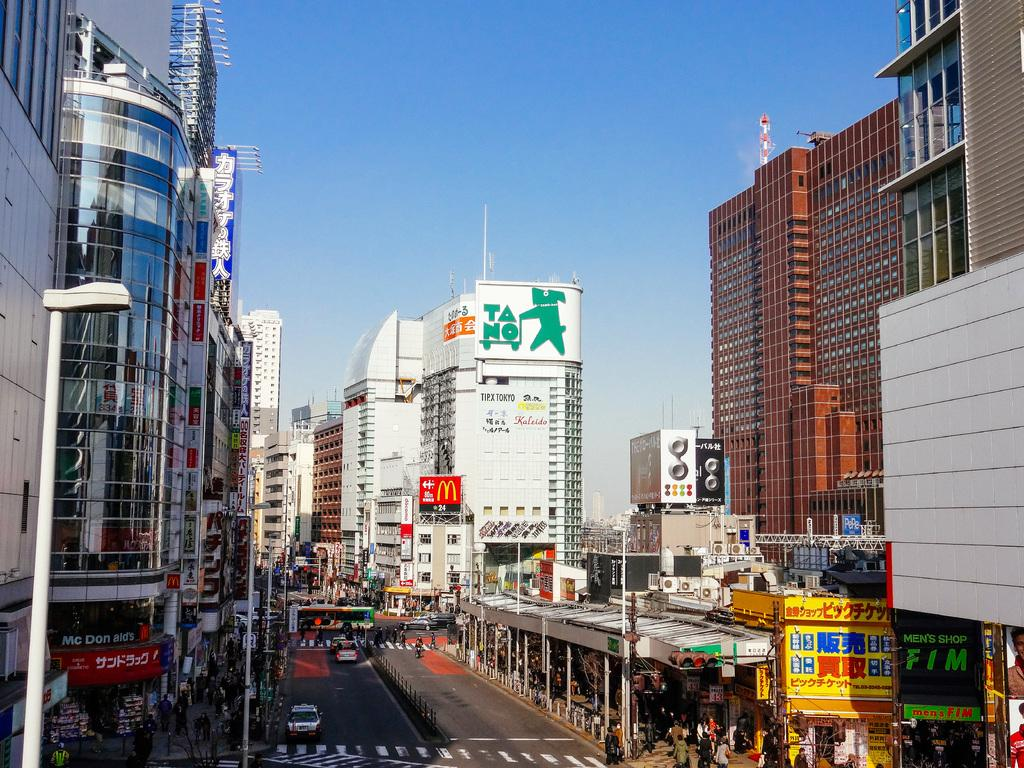Where was the image taken? The image was clicked outside. What can be seen in the background of the image? There are many buildings in the image. What is visible at the top of the image? The sky is visible at the top of the image. What is present at the bottom of the image? There is a road at the bottom of the image. How many people are in the image? There are many persons in the image. What else can be seen in the image besides people? There are vehicles in the image. What type of locket is being worn by the person in the image? There is no person wearing a locket in the image. Can you tell me how many twigs are present in the image? There are no twigs present in the image. 